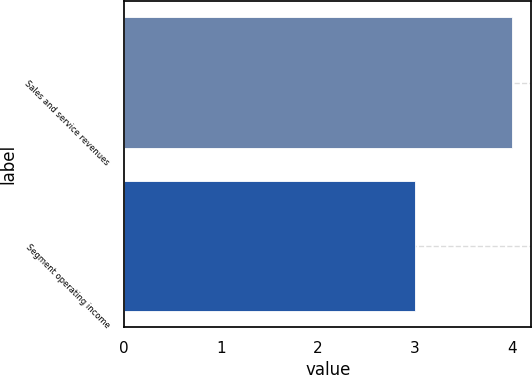Convert chart to OTSL. <chart><loc_0><loc_0><loc_500><loc_500><bar_chart><fcel>Sales and service revenues<fcel>Segment operating income<nl><fcel>4<fcel>3<nl></chart> 